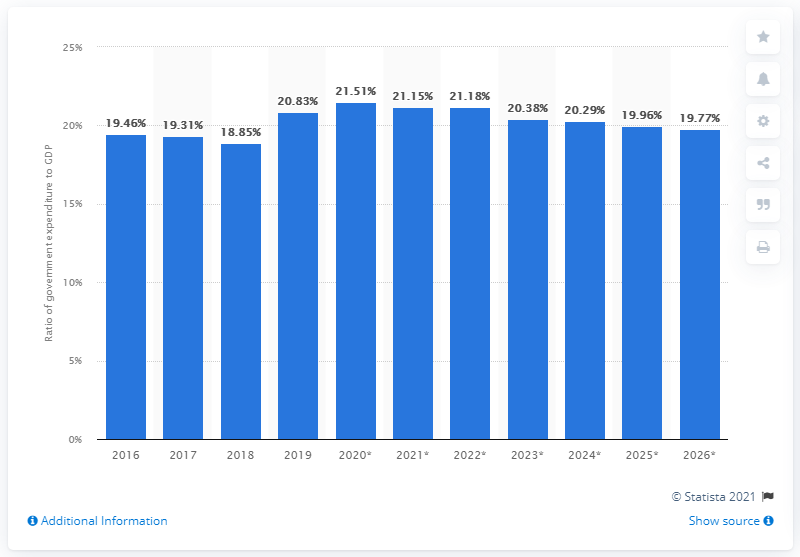What percentage of Sri Lanka's GDP did government expenditure amount to in 2019?
 20.83 